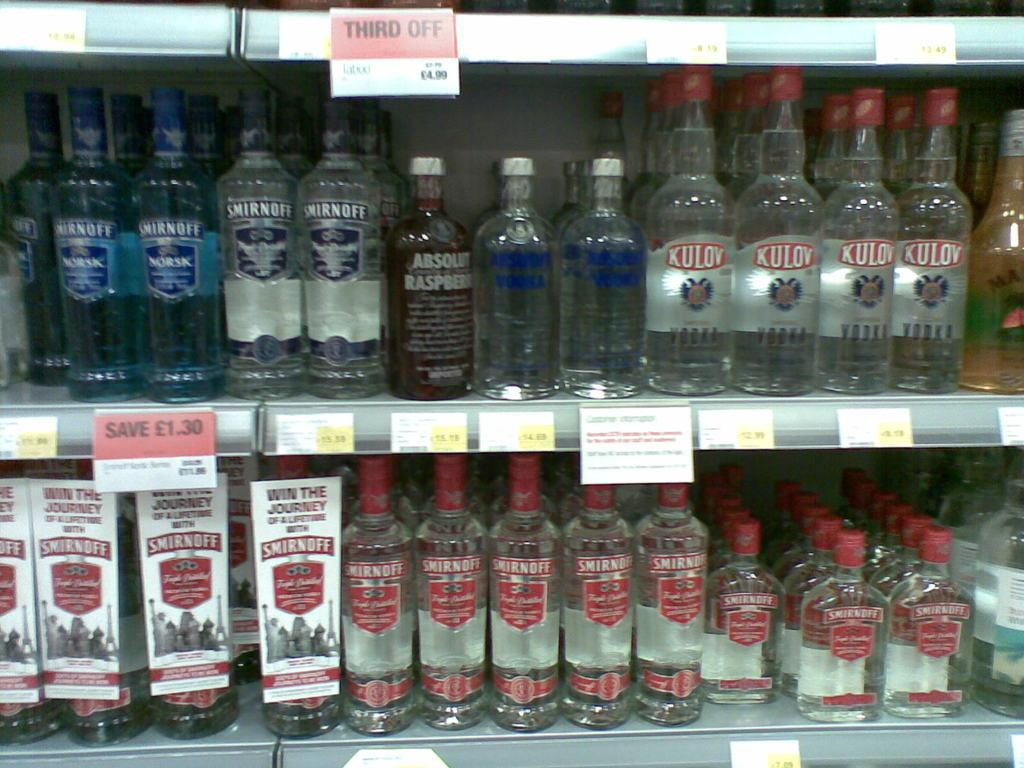<image>
Provide a brief description of the given image. A set of bottles that are sitting on a self some are called Kulov. 